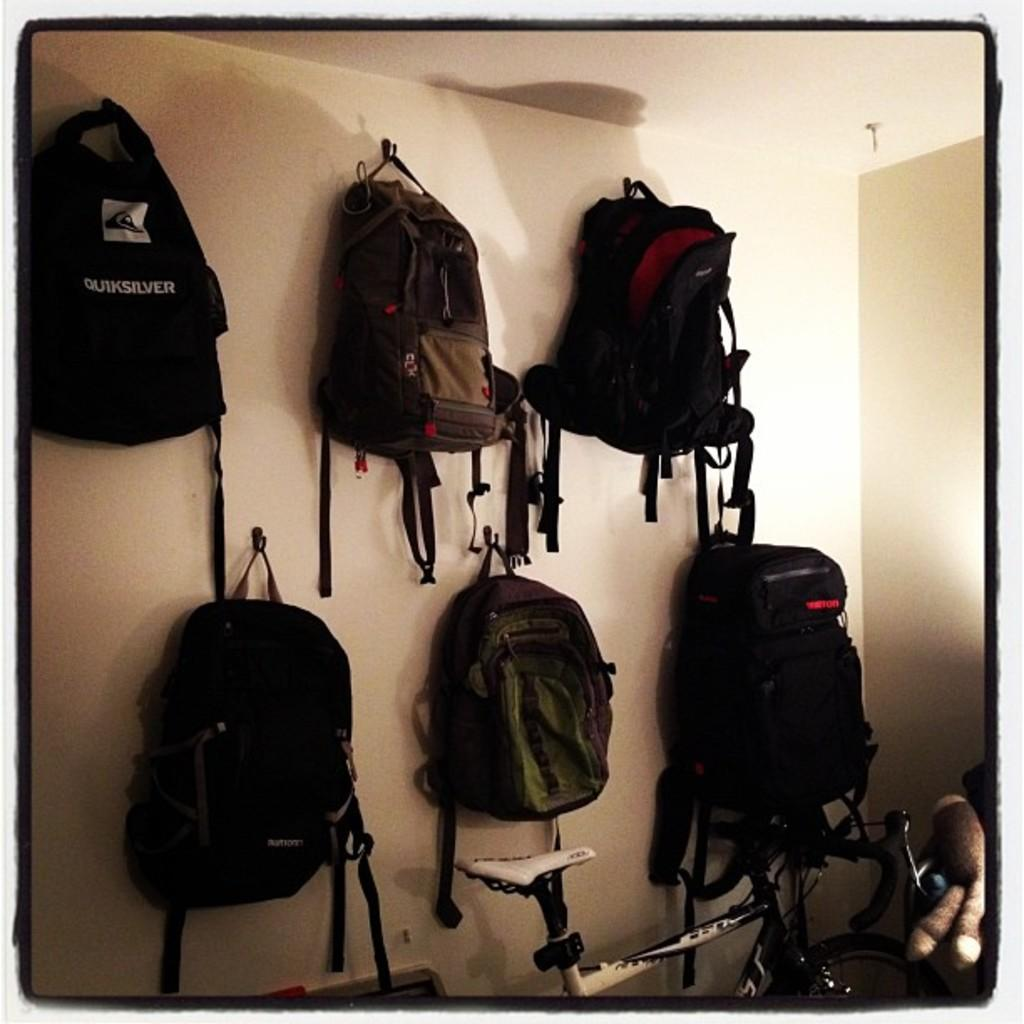What is hanging on the wall in the image? There are bags hanged on a wall in the image. What type of object can be seen in the image besides the bags on the wall? There is a toy and a bicycle in the image. What type of beetle can be seen participating in the feast in the image? There is no beetle or feast present in the image. What class is being taught in the image? There is no class or educational setting depicted in the image. 